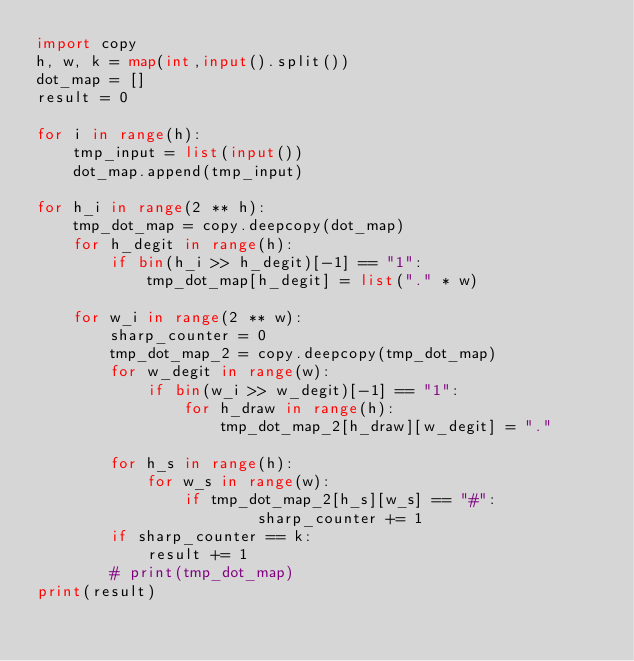<code> <loc_0><loc_0><loc_500><loc_500><_Python_>import copy
h, w, k = map(int,input().split())
dot_map = []
result = 0

for i in range(h):
    tmp_input = list(input())
    dot_map.append(tmp_input)

for h_i in range(2 ** h):
    tmp_dot_map = copy.deepcopy(dot_map)
    for h_degit in range(h):
        if bin(h_i >> h_degit)[-1] == "1":
            tmp_dot_map[h_degit] = list("." * w)

    for w_i in range(2 ** w):
        sharp_counter = 0
        tmp_dot_map_2 = copy.deepcopy(tmp_dot_map)
        for w_degit in range(w):
            if bin(w_i >> w_degit)[-1] == "1":
                for h_draw in range(h):
                    tmp_dot_map_2[h_draw][w_degit] = "."

        for h_s in range(h):
            for w_s in range(w):
                if tmp_dot_map_2[h_s][w_s] == "#":
                        sharp_counter += 1
        if sharp_counter == k:
            result += 1
        # print(tmp_dot_map)
print(result)
</code> 